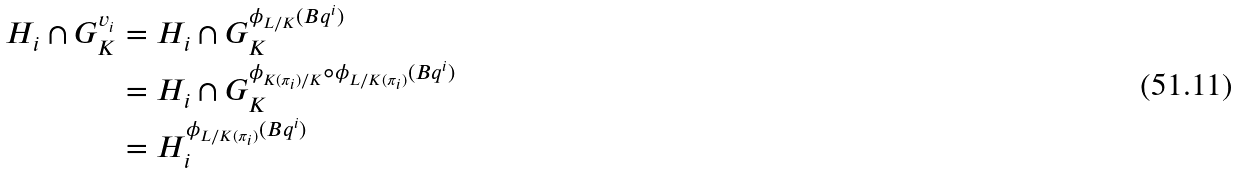<formula> <loc_0><loc_0><loc_500><loc_500>H _ { i } \cap G _ { K } ^ { v _ { i } } & = H _ { i } \cap G _ { K } ^ { \phi _ { L / K } ( B q ^ { i } ) } \\ & = H _ { i } \cap G _ { K } ^ { \phi _ { K ( \pi _ { i } ) / K } \circ \phi _ { L / K ( \pi _ { i } ) } ( B q ^ { i } ) } \\ & = H _ { i } ^ { \phi _ { L / K ( \pi _ { i } ) } ( B q ^ { i } ) }</formula> 